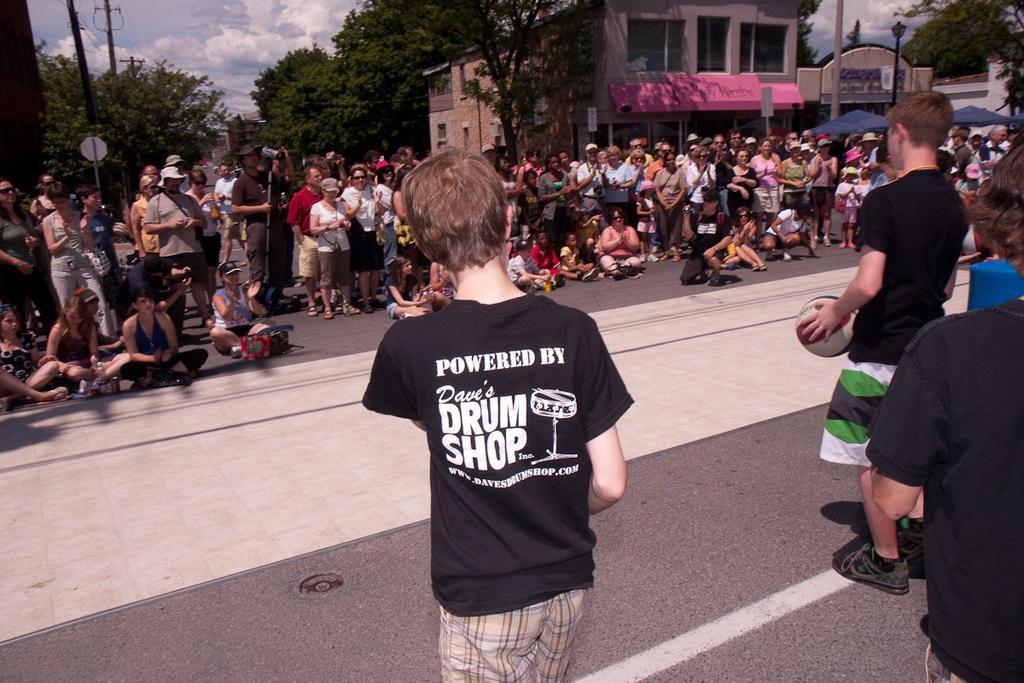Describe this image in one or two sentences. In this picture I can see so many people are on the roads, among them few people are sitting on the road, behind we can see some buildings, trees. 